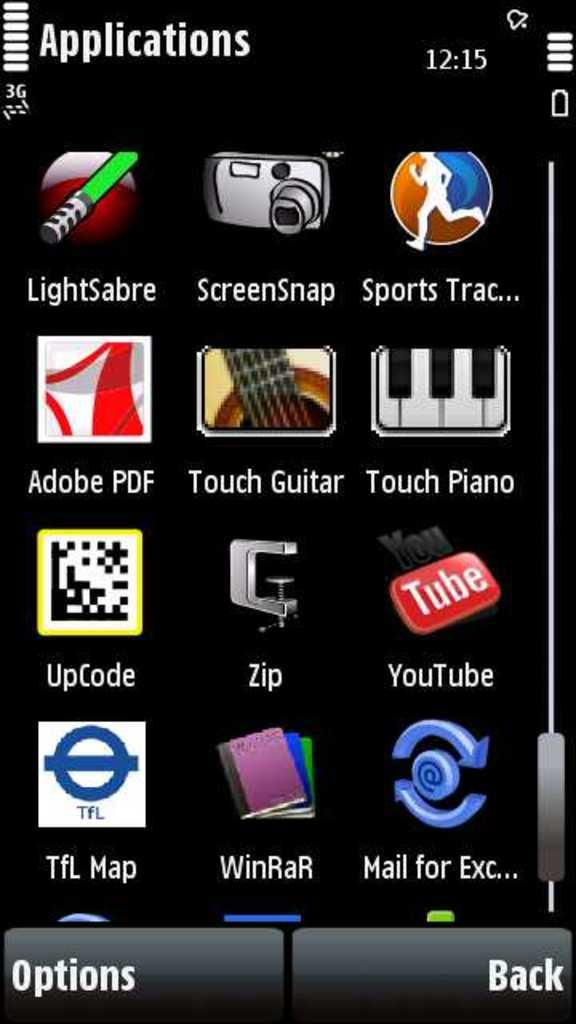<image>
Present a compact description of the photo's key features. a cell phone's applications interface including LightSabre App 